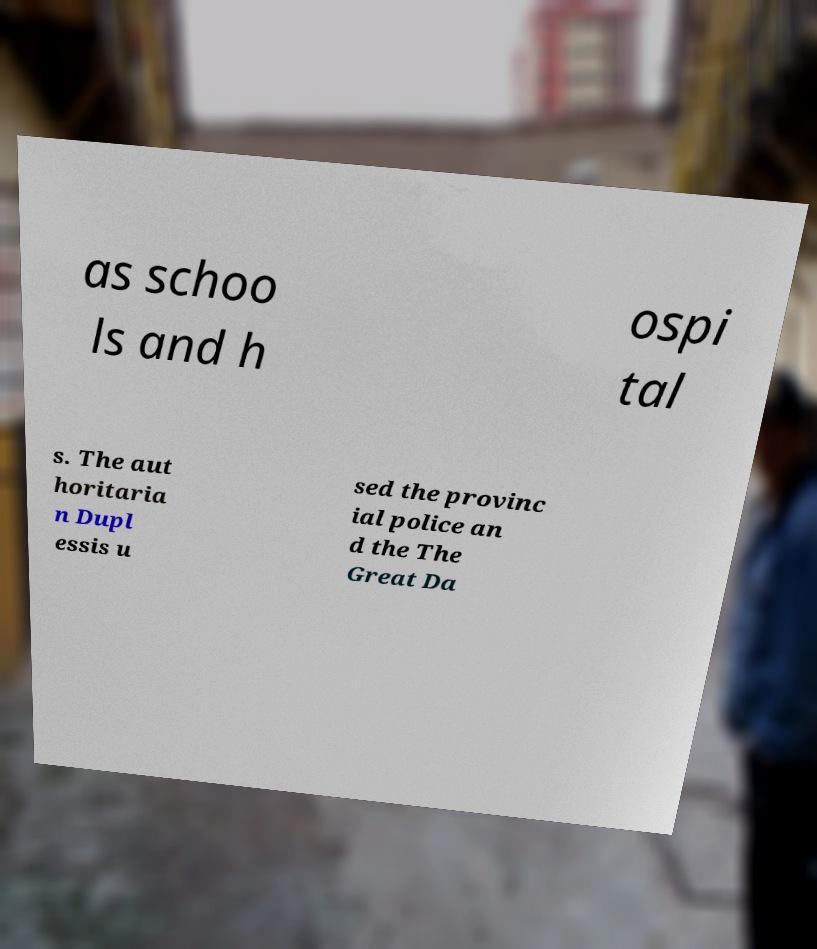Can you accurately transcribe the text from the provided image for me? as schoo ls and h ospi tal s. The aut horitaria n Dupl essis u sed the provinc ial police an d the The Great Da 